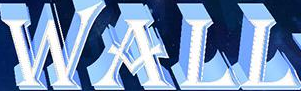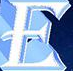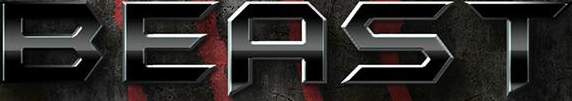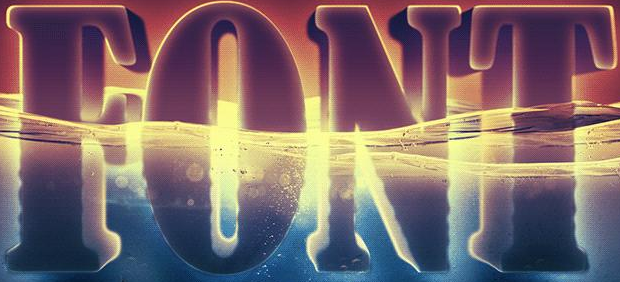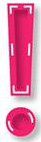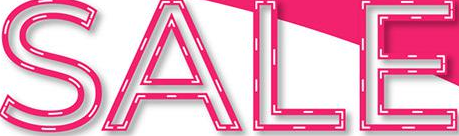What words are shown in these images in order, separated by a semicolon? WALL; E; BEAST; FONT; !; SALE 